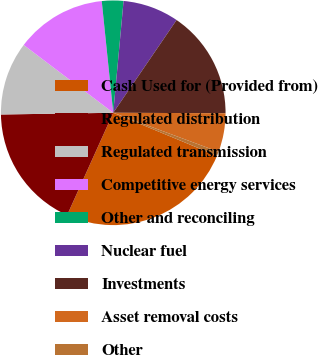Convert chart. <chart><loc_0><loc_0><loc_500><loc_500><pie_chart><fcel>Cash Used for (Provided from)<fcel>Regulated distribution<fcel>Regulated transmission<fcel>Competitive energy services<fcel>Other and reconciling<fcel>Nuclear fuel<fcel>Investments<fcel>Asset removal costs<fcel>Other<nl><fcel>25.48%<fcel>18.02%<fcel>10.56%<fcel>13.05%<fcel>3.1%<fcel>8.07%<fcel>15.53%<fcel>5.58%<fcel>0.61%<nl></chart> 